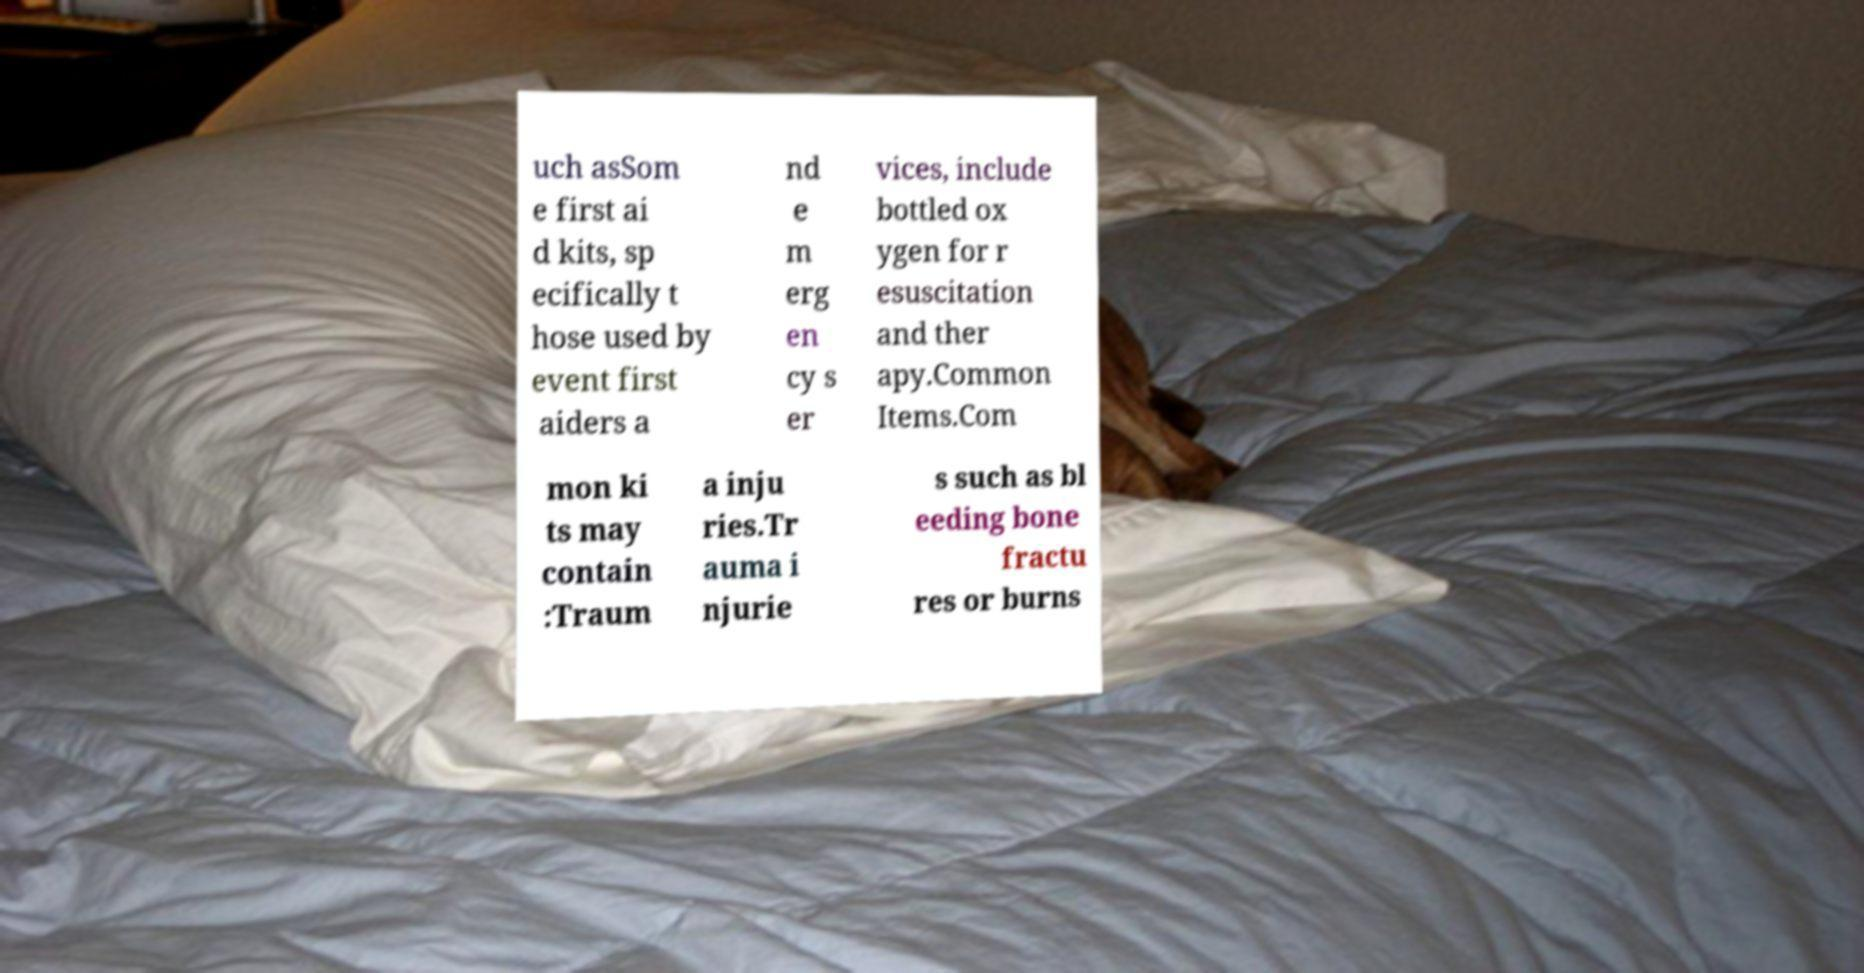Can you read and provide the text displayed in the image?This photo seems to have some interesting text. Can you extract and type it out for me? uch asSom e first ai d kits, sp ecifically t hose used by event first aiders a nd e m erg en cy s er vices, include bottled ox ygen for r esuscitation and ther apy.Common Items.Com mon ki ts may contain :Traum a inju ries.Tr auma i njurie s such as bl eeding bone fractu res or burns 